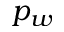<formula> <loc_0><loc_0><loc_500><loc_500>p _ { w }</formula> 